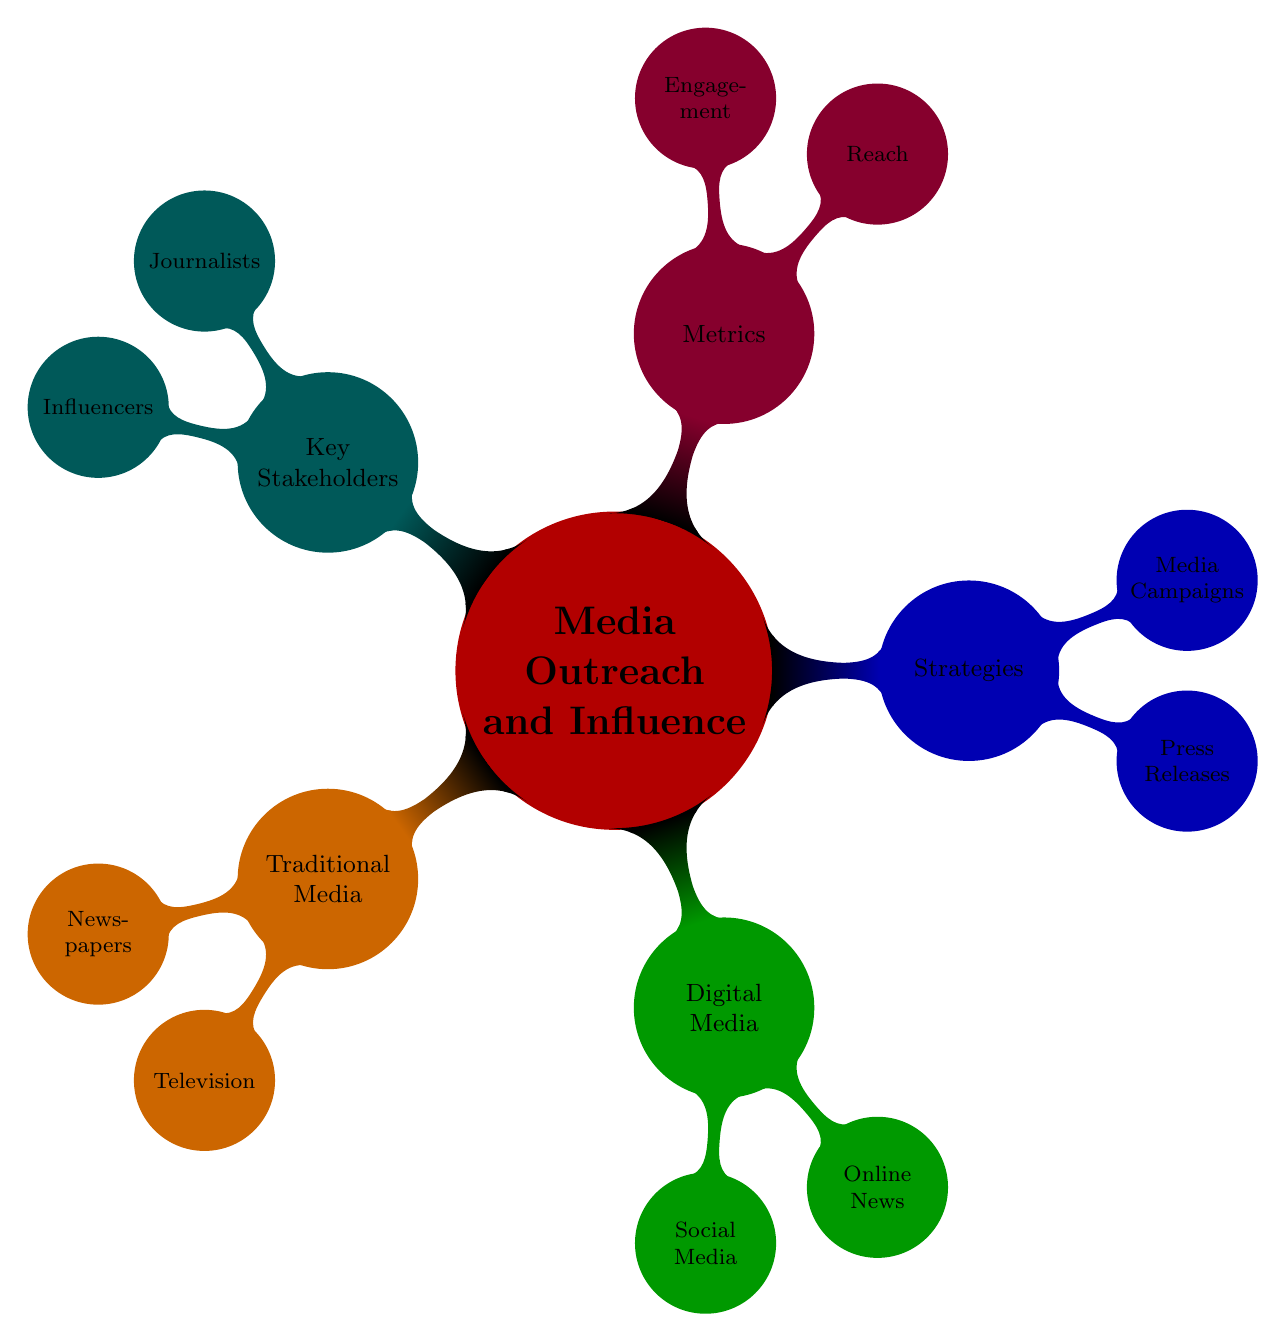What are the two main categories of media in the diagram? The diagram categorizes media into "Traditional Media" and "Digital Media." These categories are the top-level nodes branching from "Media Outreach and Influence."
Answer: Traditional Media, Digital Media How many types of traditional media are listed? The "Traditional Media" node has two child nodes, "Newspapers" and "Television," which makes a total of two types listed.
Answer: 2 What are the metrics used to evaluate media outreach? Under the "Metrics" node, the diagram lists "Reach" and "Engagement" as the key metrics used to evaluate media outreach effectiveness.
Answer: Reach, Engagement Which strategy involves press distribution services? The "Press Releases" node under the "Strategies" category contains "Press Distribution Services," which is a specific aspect of this strategy.
Answer: Press Distribution Services Who are considered influencers according to the diagram? The "Influencers" node under "Key Stakeholders" specifies "Bloggers," "Youtubers," and "Industry Experts" as the groups that fall under this category.
Answer: Bloggers, Youtubers, Industry Experts What is the relationship between "Media Campaigns" and "Sponsored Content"? "Sponsored Content" falls under the "Media Campaigns" node, indicating that it is one of the specific strategies used in a media campaign.
Answer: Sponsored Content is a part of Media Campaigns How many social media platforms are listed under digital media? The "Social Media" node under "Digital Media" lists three platforms: "Twitter," "Facebook," and "Instagram." Thus, there are three social media platforms mentioned.
Answer: 3 What type of engagement metrics are mentioned in the diagram? Under the "Engagement" metric, the diagram identifies "Comments," "Shares," and "Likes" as key forms of interaction to measure engagement.
Answer: Comments, Shares, Likes Which type of media includes "HuffPost"? "HuffPost" is categorized under the "Online News" node, which is a subcategory of "Digital Media." This association defines where HuffPost falls in the media landscape.
Answer: Online News 